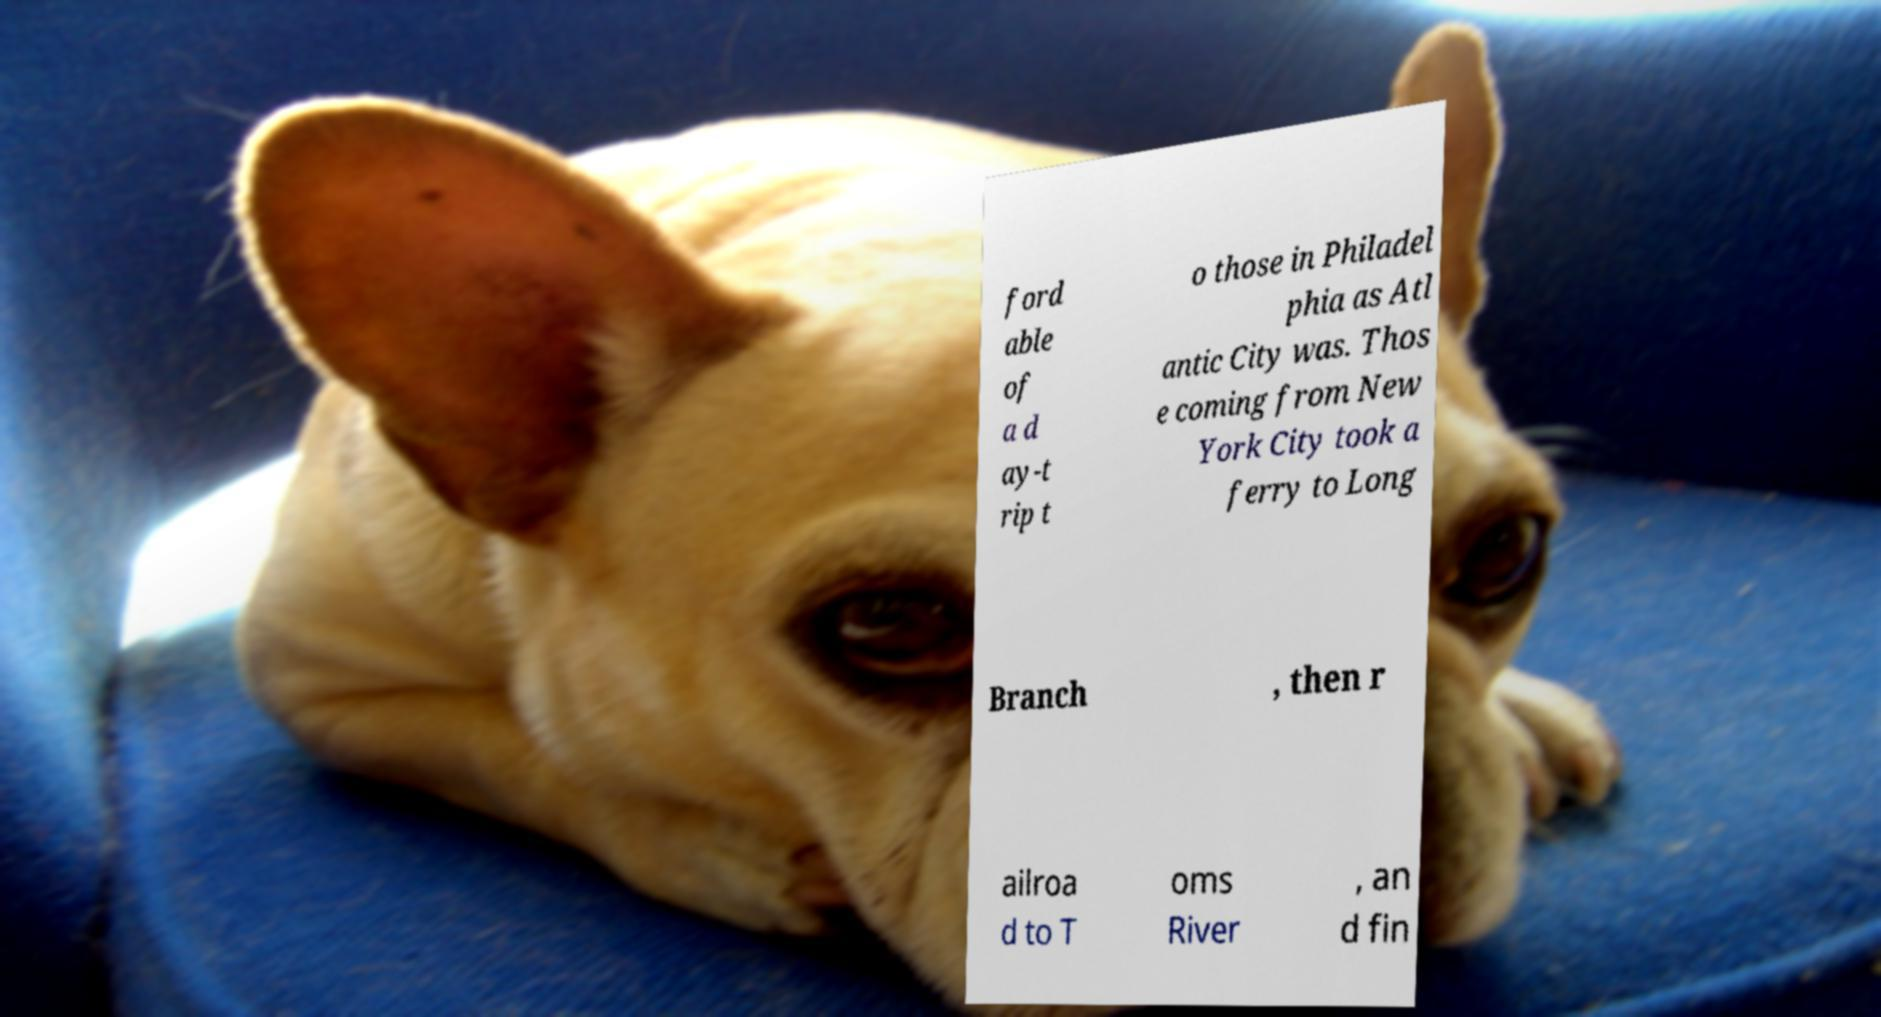What messages or text are displayed in this image? I need them in a readable, typed format. ford able of a d ay-t rip t o those in Philadel phia as Atl antic City was. Thos e coming from New York City took a ferry to Long Branch , then r ailroa d to T oms River , an d fin 